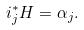<formula> <loc_0><loc_0><loc_500><loc_500>i _ { j } ^ { * } H = \alpha _ { j } .</formula> 